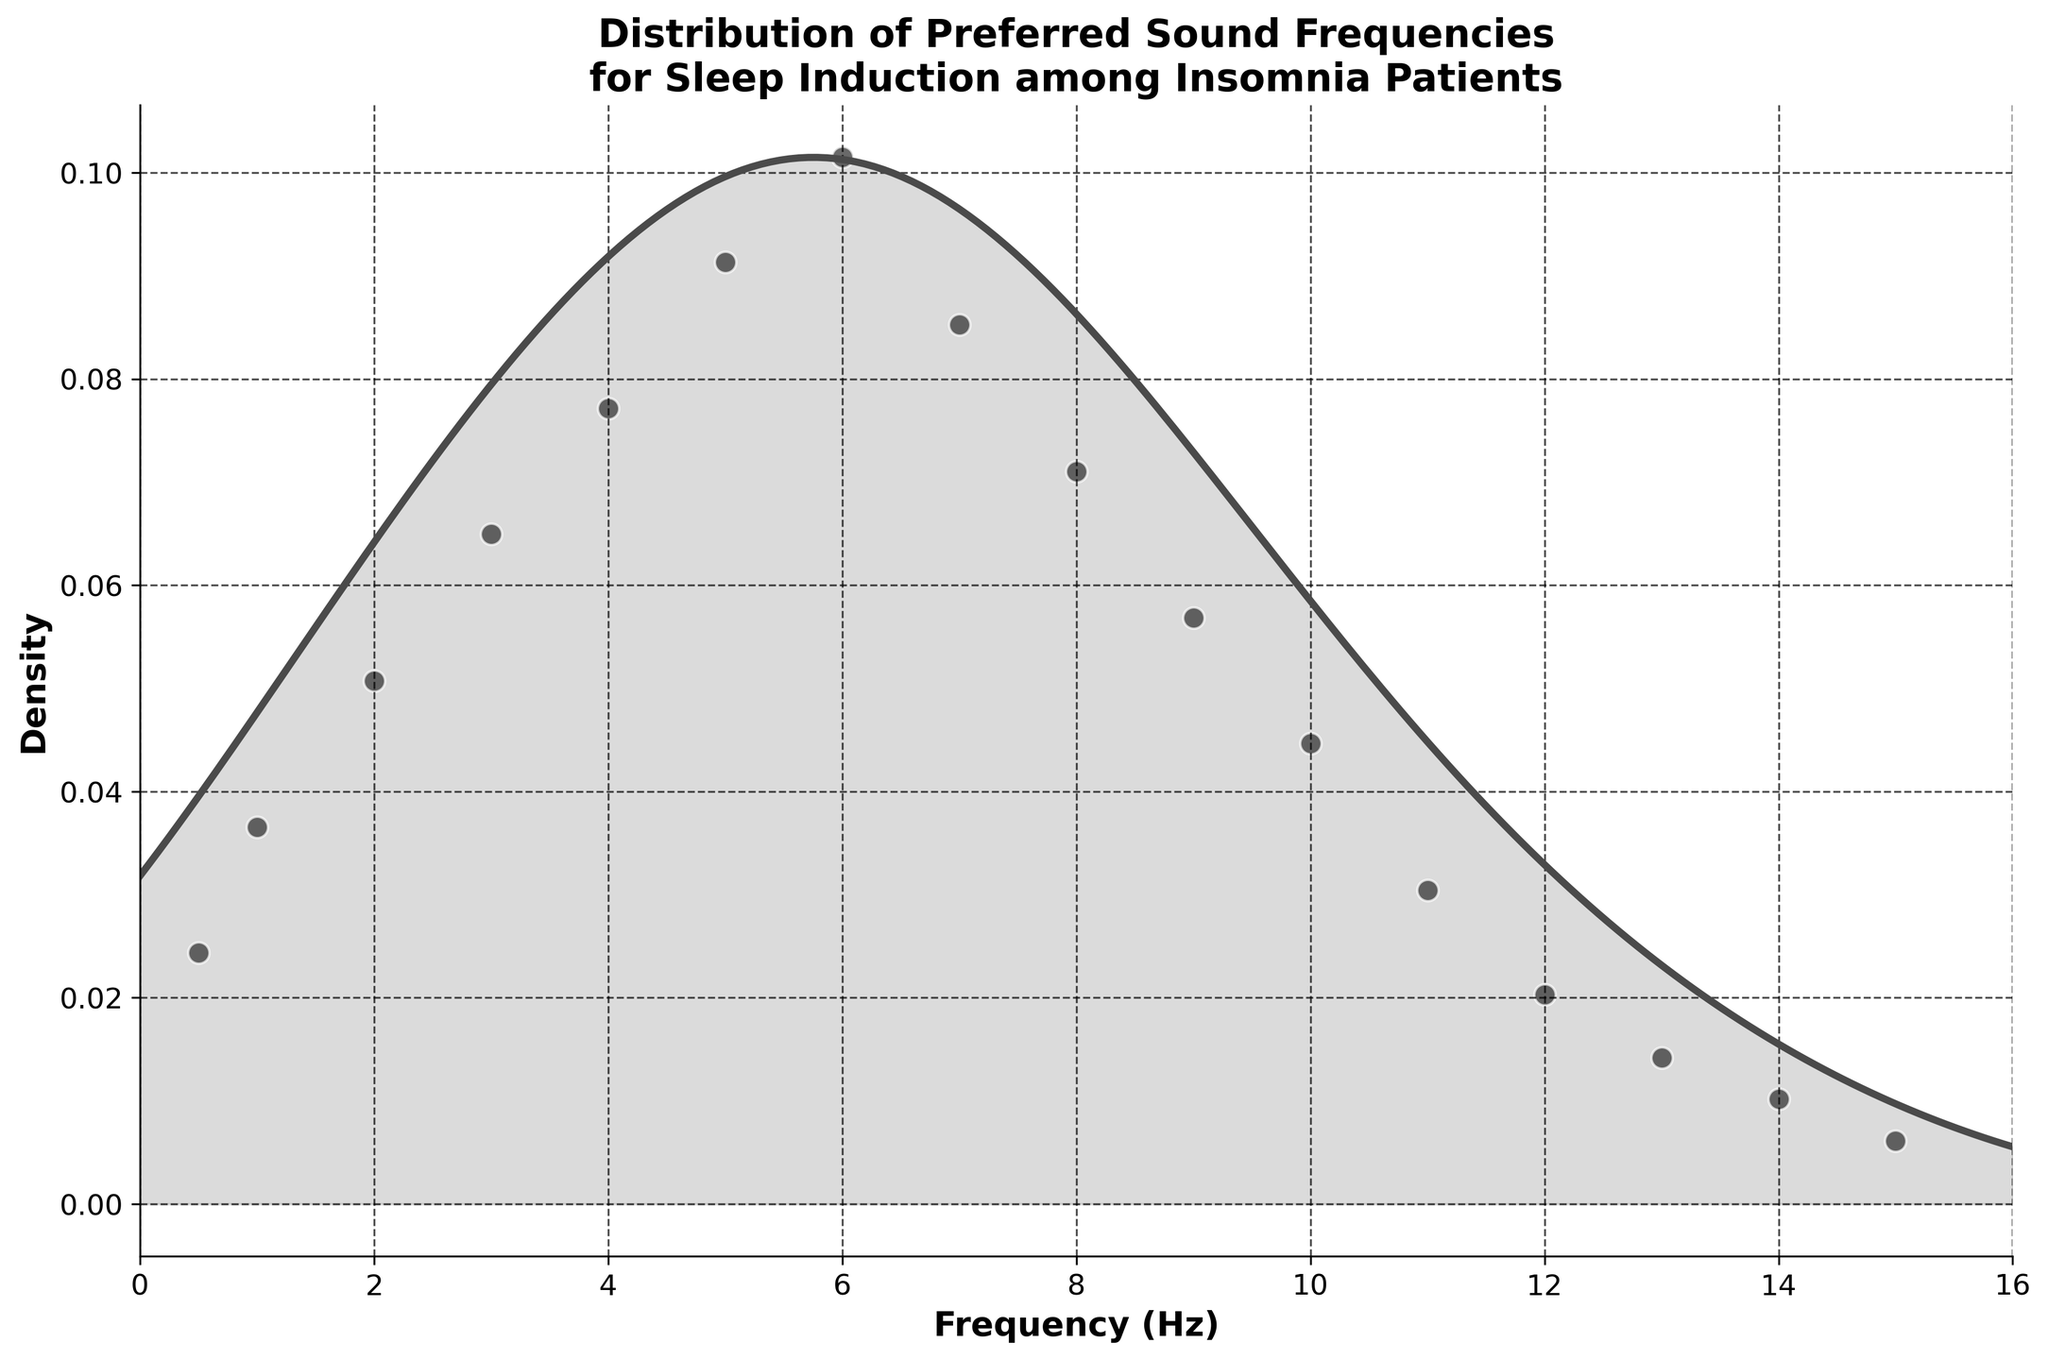What is the title of the plot? The title is displayed at the top center of the plot. It provides a summary of the plot's subject matter.
Answer: Distribution of Preferred Sound Frequencies for Sleep Induction among Insomnia Patients What is the range of the x-axis? The x-axis represents the frequency in Hz and it ranges from 0 to 16 as seen on both ends of the axis.
Answer: 0 to 16 Hz What is the peak frequency with the highest density? Observe where the density curve reaches its highest point along the frequency axis.
Answer: Around 6 Hz How many peaks can you identify in the density plot? Looking at where the density curve has local maxima, i.e., where it goes up and then down again.
Answer: One peak What frequency has the highest count originally plotted as scatter points? Among the scatter points, the highest represents the largest count from the data provided.
Answer: 6 Hz At which frequency does the density start to drop significantly after reaching its peak? Identify the frequency value where the density curve starts to decline noticeably after the peak.
Answer: Around 7 Hz What is the rough density value at 6 Hz, considering the plot's density curve? Estimate the height of the density curve at the frequency value of 6 Hz.
Answer: Around 0.12 Compare the density at 3 Hz and 12 Hz, which one is higher? Look at the density curve's height at these specific frequency values and compare them.
Answer: 3 Hz How does the density at 10 Hz compare to the density at 2 Hz? Observe and compare the height of the density curve at 10 Hz and 2 Hz.
Answer: Density at 2 Hz is higher than at 10 Hz From the scatter points, what’s the lowest frequency that has non-zero counts? Identify the leftmost scatter point on the x-axis which indicates the lowest frequency with counts.
Answer: 0.5 Hz 